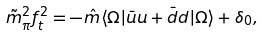<formula> <loc_0><loc_0><loc_500><loc_500>\tilde { m } _ { \pi } ^ { 2 } f _ { t } ^ { 2 } = - \hat { m } \langle \Omega | \bar { u } u + \bar { d } d | \Omega \rangle + \delta _ { 0 } ,</formula> 